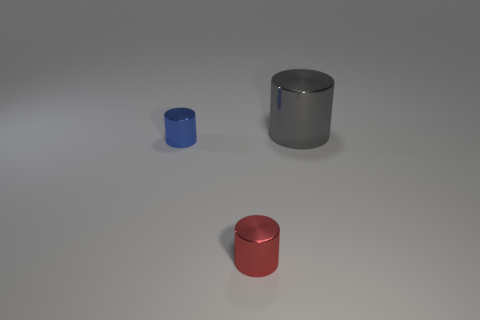What is the tiny thing that is on the right side of the blue shiny object made of?
Keep it short and to the point. Metal. What material is the other red object that is the same shape as the big object?
Your response must be concise. Metal. There is a large cylinder that is behind the tiny red metallic cylinder; are there any big metal things behind it?
Keep it short and to the point. No. Do the large object and the tiny red object have the same shape?
Offer a terse response. Yes. What shape is the blue thing that is the same material as the gray thing?
Provide a short and direct response. Cylinder. There is a gray object that is on the right side of the small blue metal cylinder; is its size the same as the object in front of the small blue cylinder?
Provide a succinct answer. No. Is the number of blue cylinders that are on the right side of the large gray object greater than the number of large metallic cylinders left of the red cylinder?
Your response must be concise. No. What number of other things are there of the same color as the big cylinder?
Your answer should be compact. 0. Do the large cylinder and the tiny cylinder on the right side of the blue object have the same color?
Make the answer very short. No. What number of tiny cylinders are in front of the metal cylinder that is to the left of the red metallic object?
Offer a very short reply. 1. 